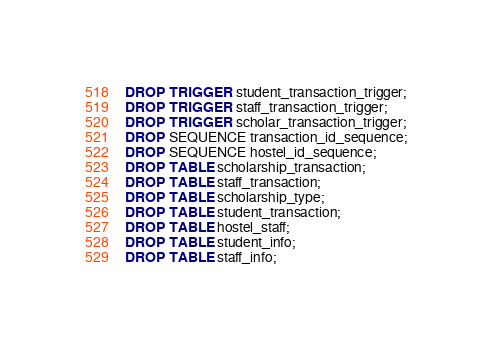Convert code to text. <code><loc_0><loc_0><loc_500><loc_500><_SQL_>DROP TRIGGER student_transaction_trigger;
DROP TRIGGER staff_transaction_trigger;
DROP TRIGGER scholar_transaction_trigger;
DROP SEQUENCE transaction_id_sequence;
DROP SEQUENCE hostel_id_sequence;
DROP TABLE scholarship_transaction;
DROP TABLE staff_transaction;
DROP TABLE scholarship_type;
DROP TABLE student_transaction;
DROP TABLE hostel_staff;
DROP TABLE student_info;
DROP TABLE staff_info;
</code> 